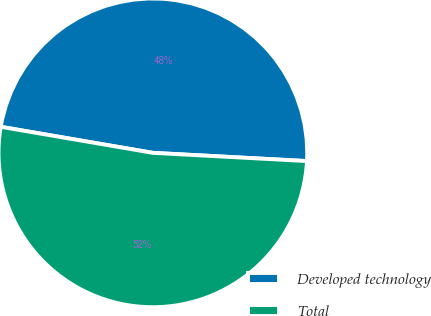Convert chart to OTSL. <chart><loc_0><loc_0><loc_500><loc_500><pie_chart><fcel>Developed technology<fcel>Total<nl><fcel>48.15%<fcel>51.85%<nl></chart> 